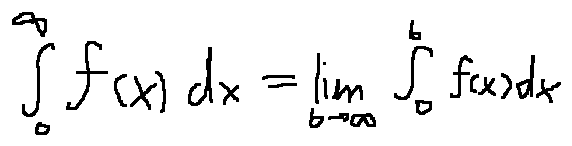Convert formula to latex. <formula><loc_0><loc_0><loc_500><loc_500>\int \lim i t s _ { 0 } ^ { \infty } f ( x ) d x = \lim \lim i t s _ { b \rightarrow \infty } \int \lim i t s _ { 0 } ^ { b } f ( x ) d x</formula> 